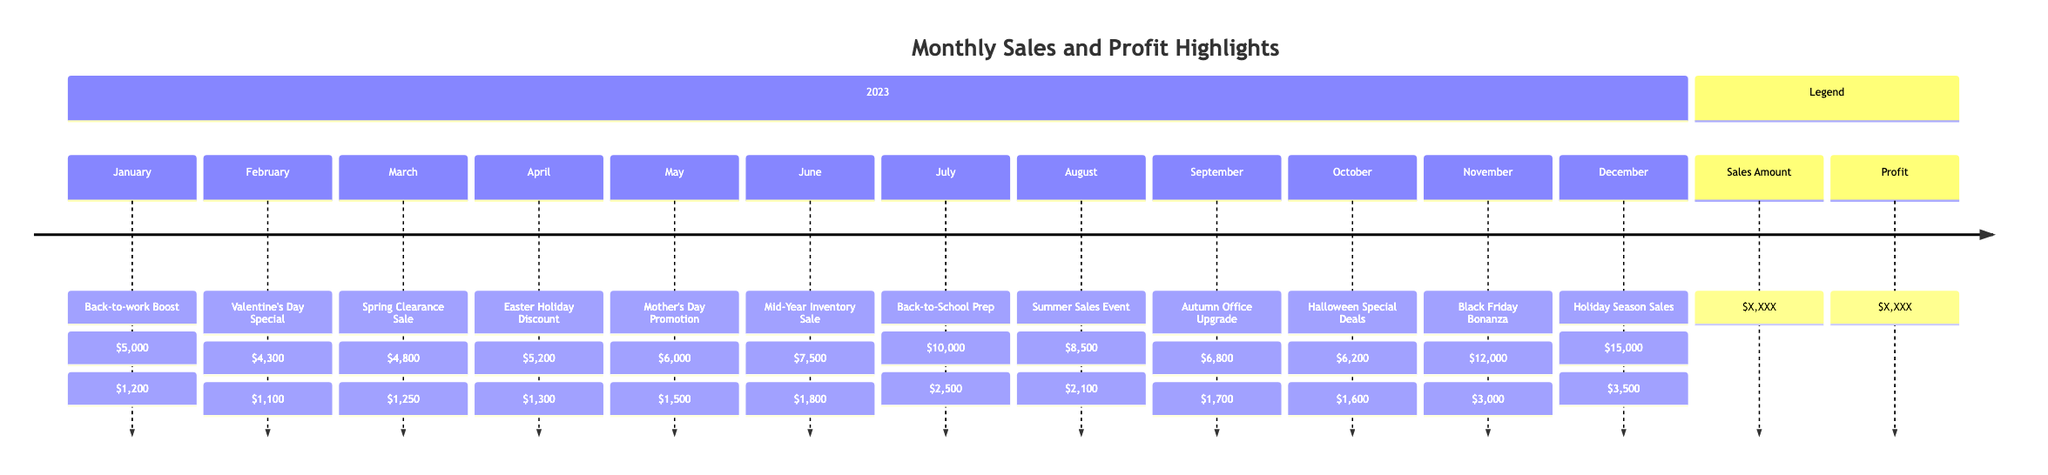What was the highest sales amount for any month? The diagram indicates that December had the highest sales amount of $15,000, which is visually highlighted amongst the other months.
Answer: $15,000 Which month had the lowest profit? By scanning through the profit values in the diagram, February shows the lowest profit of $1,100, making it clear when compared to other months.
Answer: $1,100 How much profit did the shop make in July? Looking at the July entry in the timeline, the profit shown is $2,500, which is stated directly in the data for that month.
Answer: $2,500 What was the sales highlight for April? The timeline section for April explicitly lists "Easter Holiday Discount" as the sales highlight, as all sales highlights are associated with their respective months.
Answer: Easter Holiday Discount Which months had sales amounts greater than $10,000? The diagram shows that both July and December exceeded $10,000 in sales, with July at $10,000 and December at $15,000, requiring comparison of values for confirmation.
Answer: July and December What is the total sales amount for the second half of the year? The sales amounts for the second half (July to December) total $10,000 + $8,500 + $6,800 + $6,200 + $12,000 + $15,000, which adds up to $58,700 after calculating each month’s sales value.
Answer: $58,700 Which month had a sales highlight related to a holiday? Notable entries include April with "Easter Holiday Discount" and December with "Holiday Season Sales," indicating both months had sales highlights related to holidays upon reviewing the highlights section.
Answer: April and December What was the overall trend in profit from January to December? Examining the profit values, there is an increasing trend throughout the year, especially marked by substantial jumps in profit towards the end, from $1,200 in January to $3,500 in December, marking growth over the year.
Answer: Increasing trend What sales highlight did February offer? Referencing February's entry specifically mentions "Valentine's Day Special" as the associated sales highlight, which is a noteworthy monthly event observed in the timeline.
Answer: Valentine's Day Special 